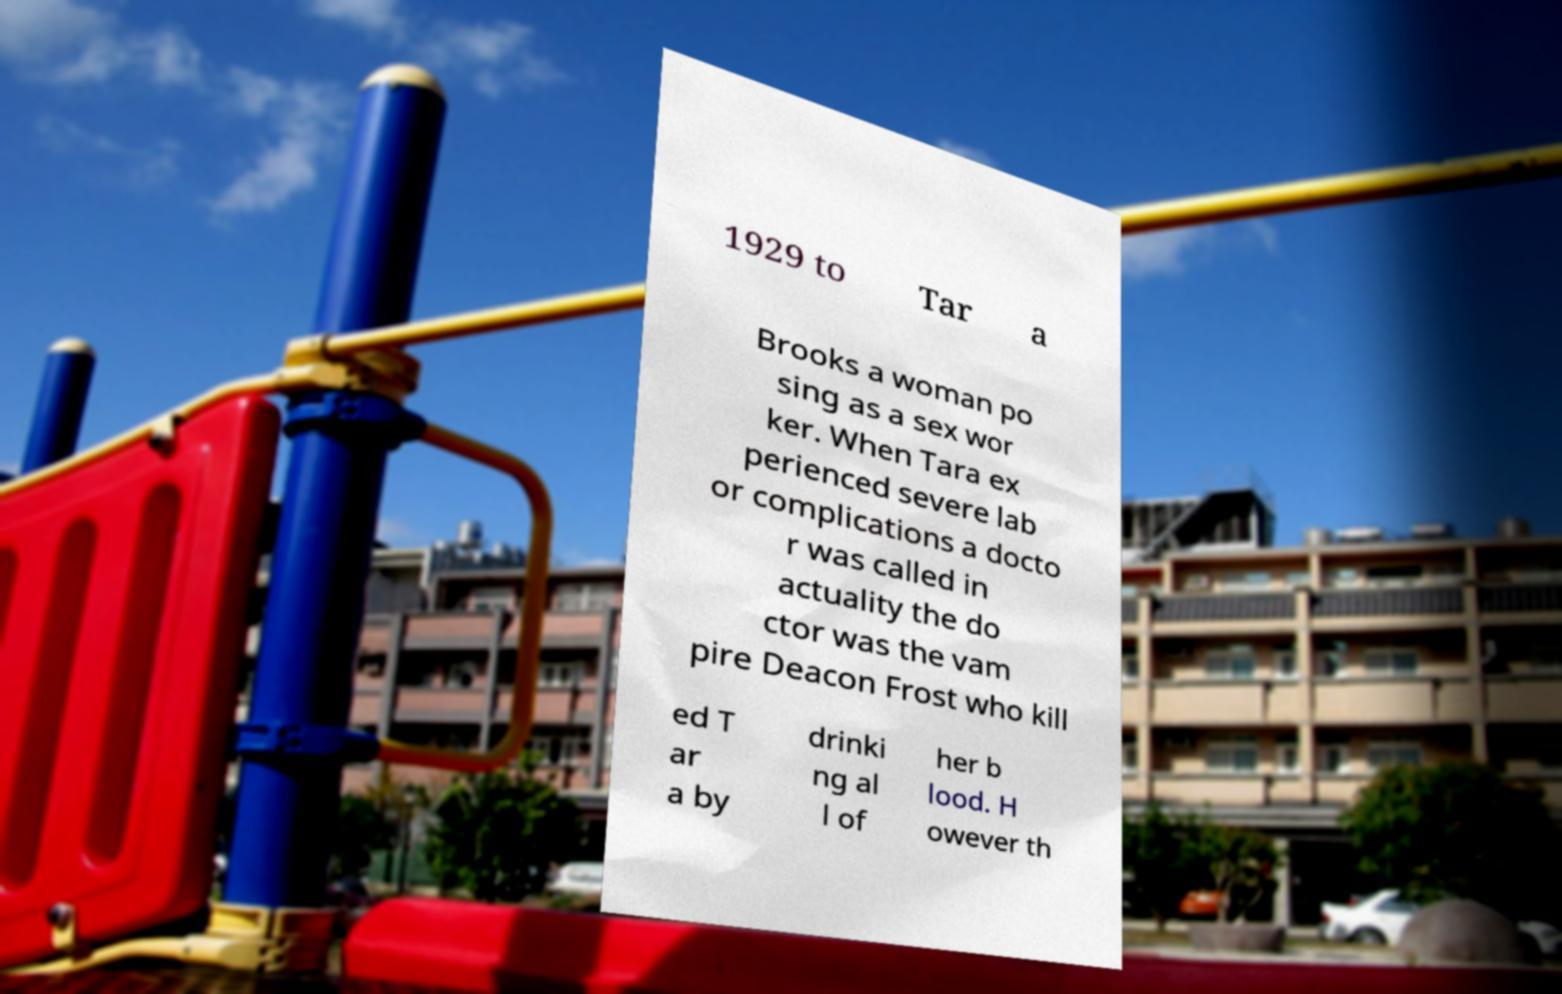I need the written content from this picture converted into text. Can you do that? 1929 to Tar a Brooks a woman po sing as a sex wor ker. When Tara ex perienced severe lab or complications a docto r was called in actuality the do ctor was the vam pire Deacon Frost who kill ed T ar a by drinki ng al l of her b lood. H owever th 